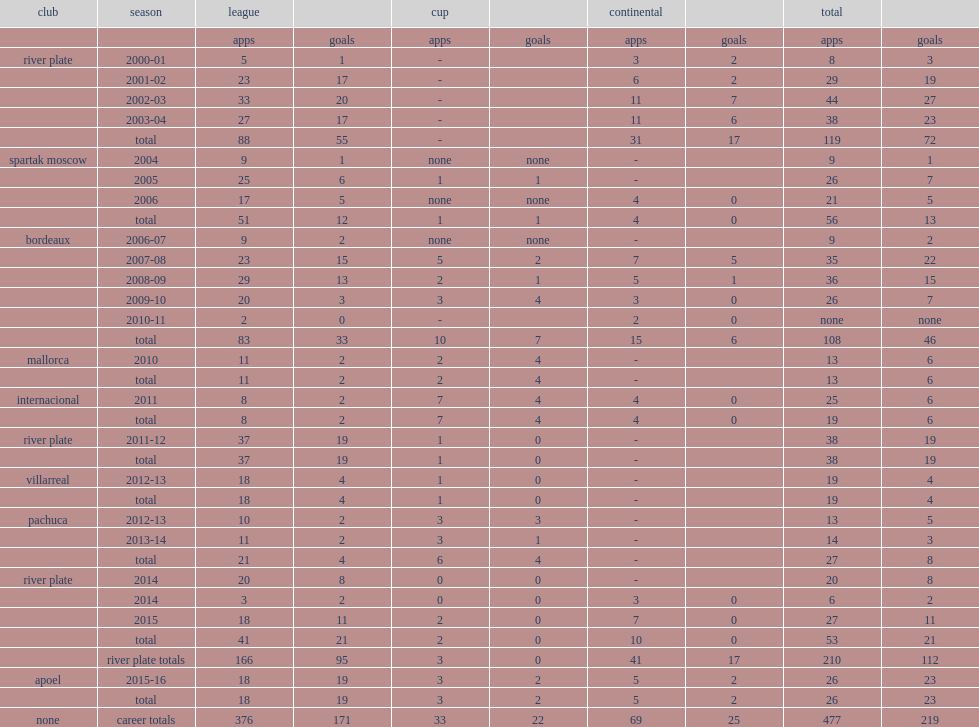How many goals did fernando cavenaghi play for river plate totally? 112.0. 